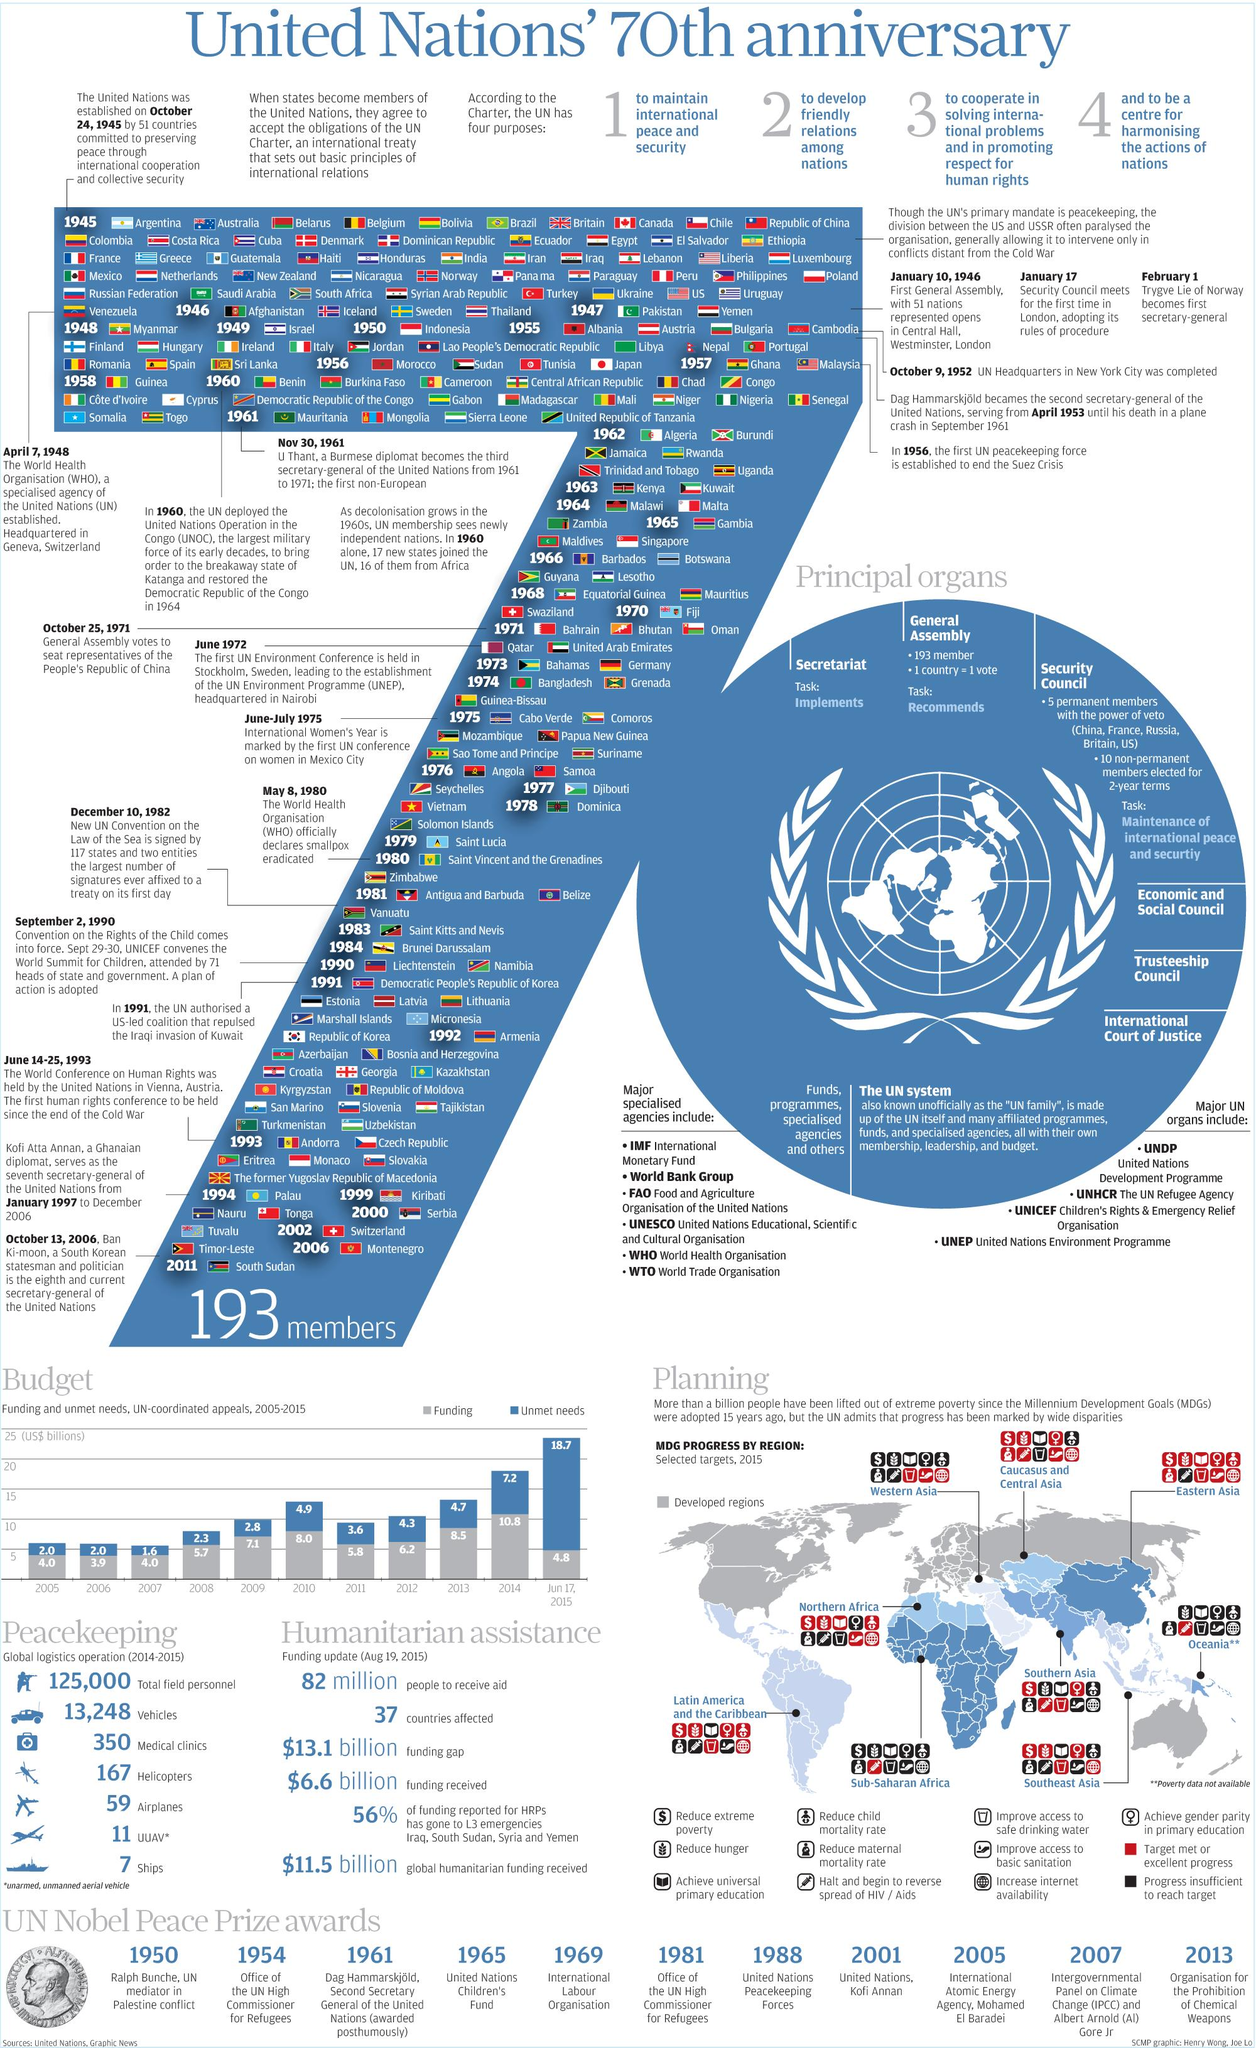List a handful of essential elements in this visual. The Caucasus and Central Asia region requires improvement in the areas of primary education, child mortality, and access to drinking water. The budget allocated the least amount of funding to two consecutive years, namely 2005 and 2007. The first Secretary General assumed office on February 1, 1946. Sub-Saharan Africa has the lowest number of Millennium Development Goal targets met, according to recent data. The third highest unmet needs in the budget were shown in the year 2010. 